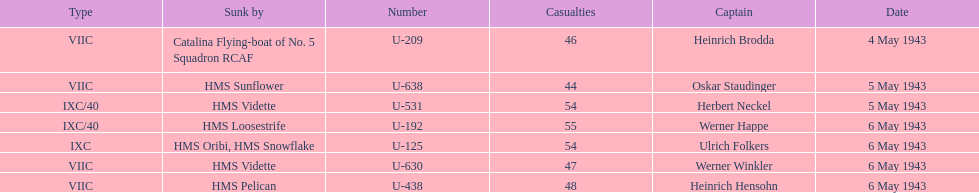What is the only vessel to sink multiple u-boats? HMS Vidette. 